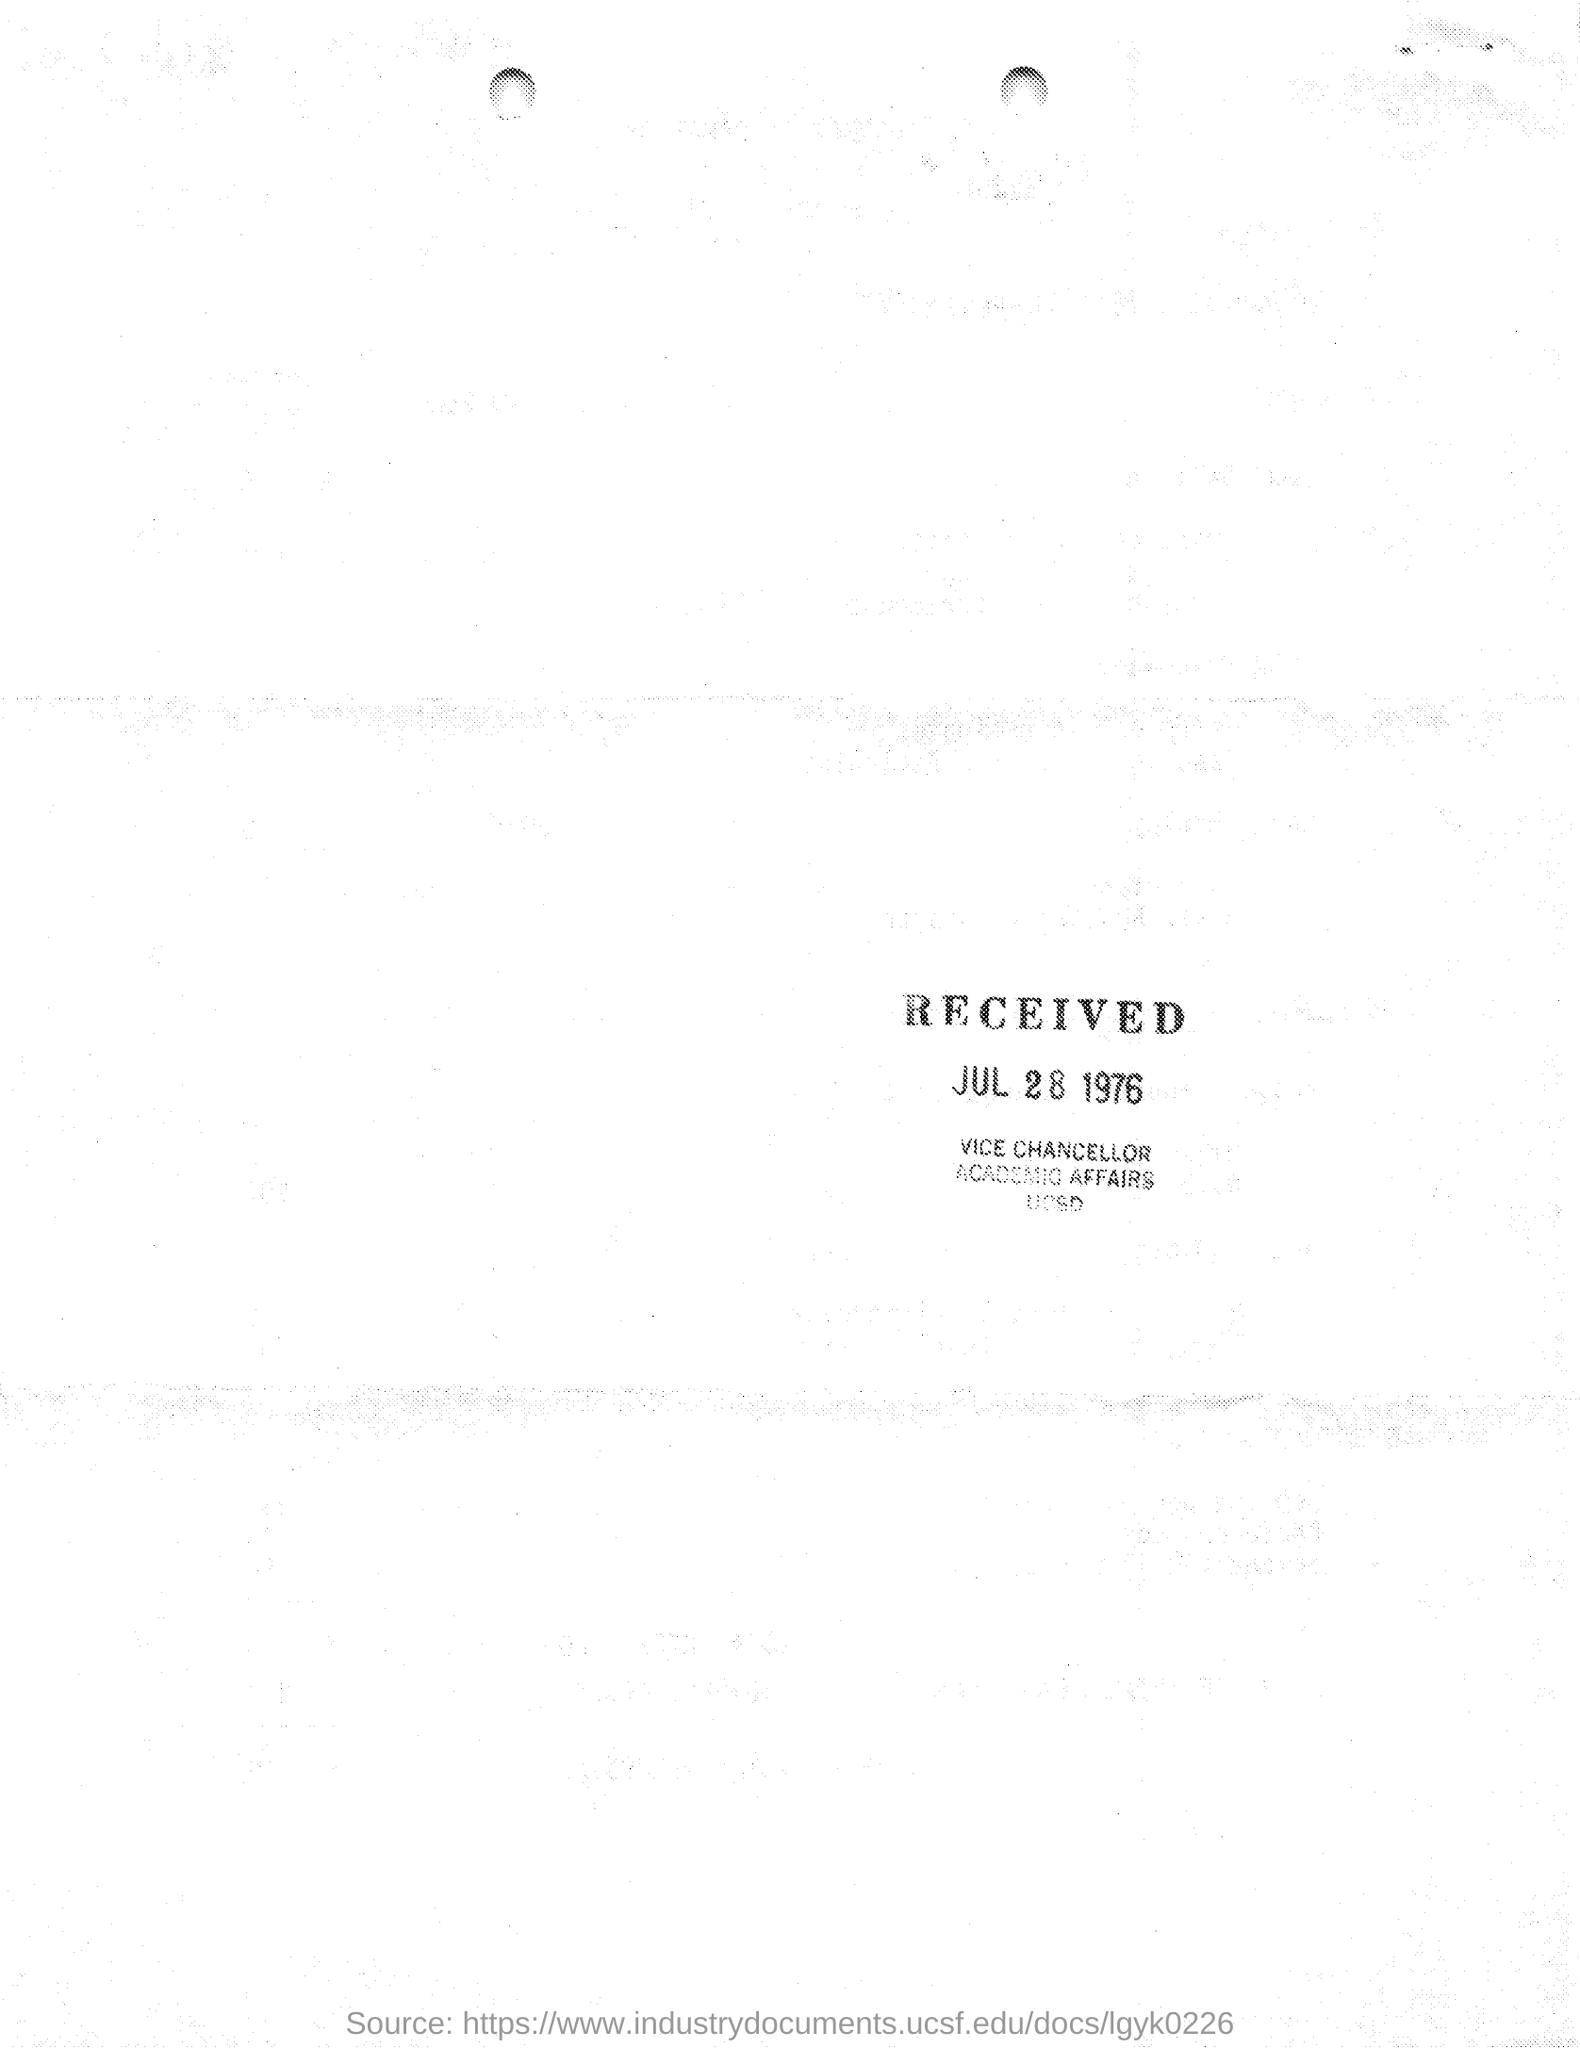Outline some significant characteristics in this image. The Vice Chancellor has issued this. On July 28, 1976, the message was received. 